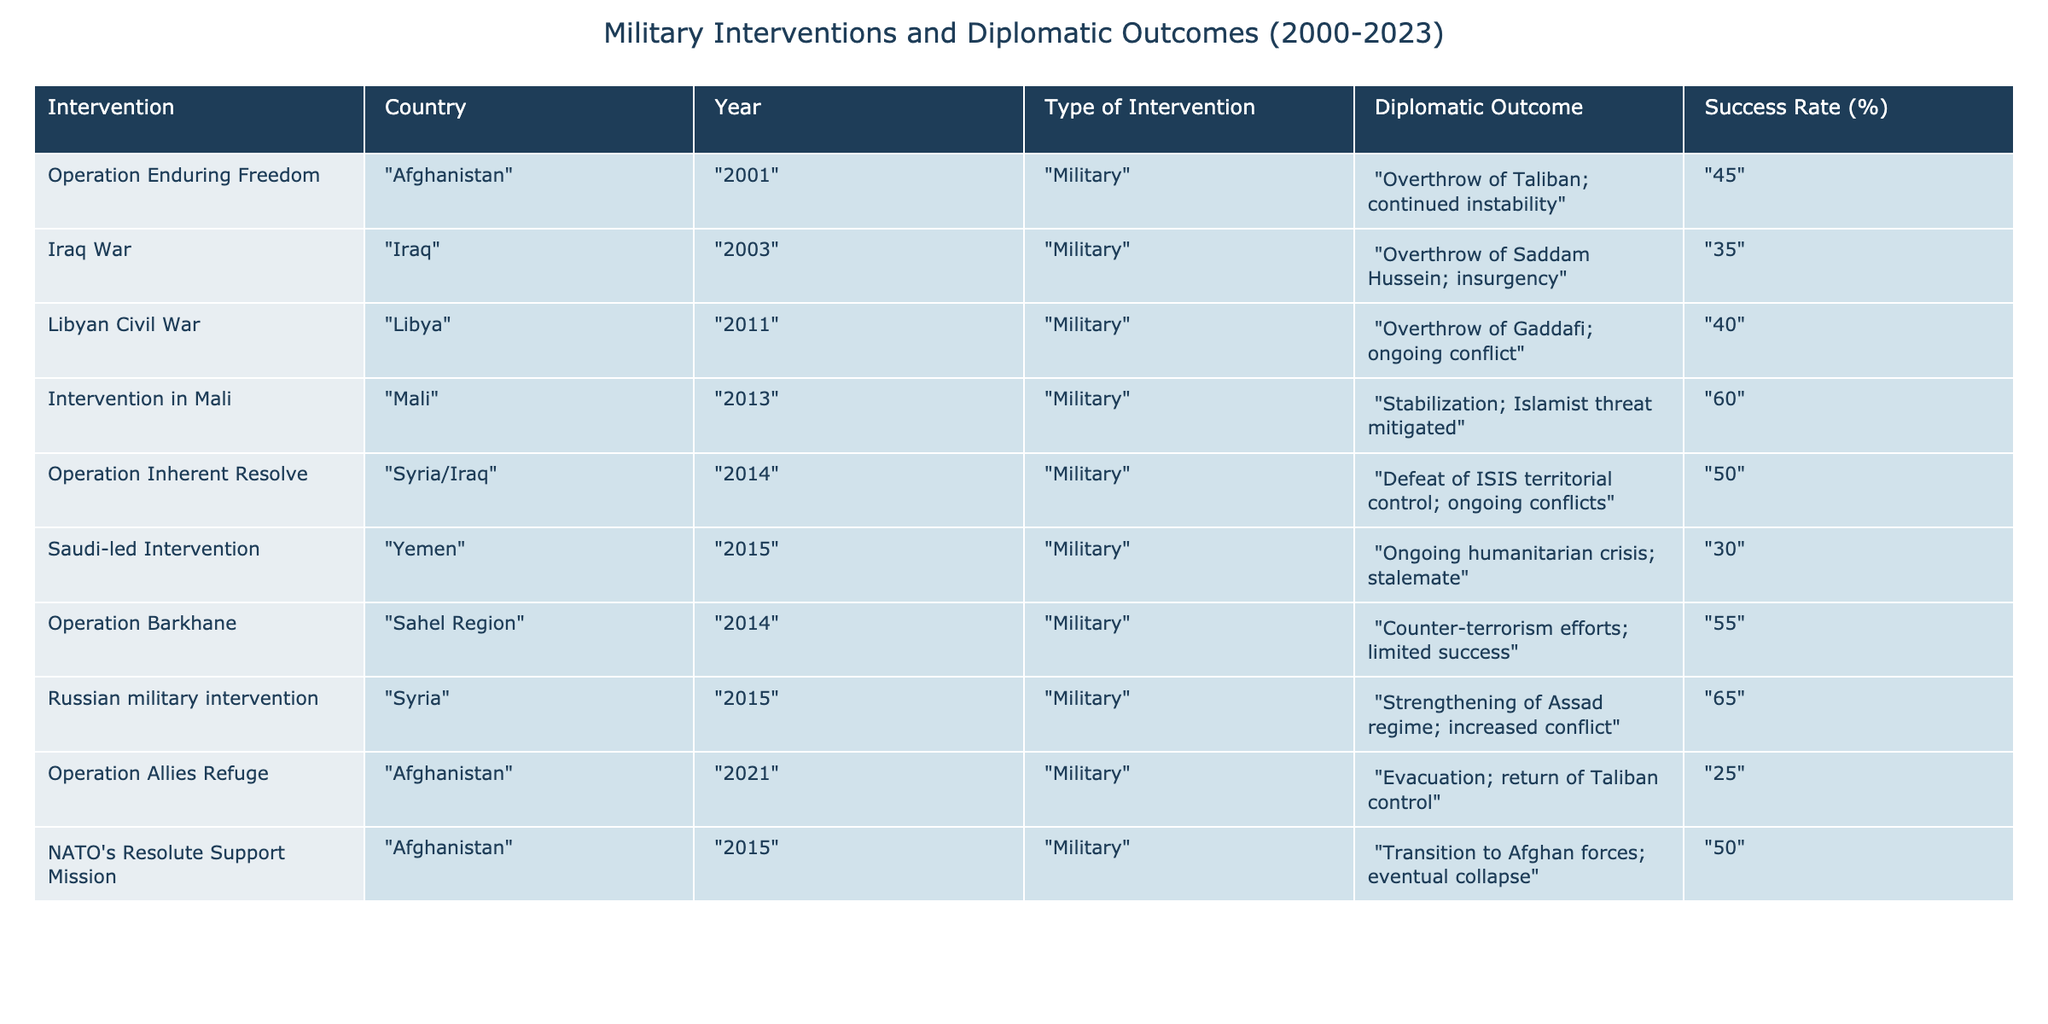What military intervention had the highest success rate? By examining the "Success Rate (%)" column, I see that the "Russian military intervention" in Syria has the highest success rate at 65%.
Answer: 65% What was the diplomatic outcome of the Iraq War? The table lists the diplomatic outcome of the Iraq War as the "Overthrow of Saddam Hussein; insurgency."
Answer: Overthrow of Saddam Hussein; insurgency Is the success rate of the Saudi-led intervention in Yemen greater than 40%? The table indicates that the success rate for the Saudi-led intervention in Yemen is 30%, which is not greater than 40%.
Answer: No What is the average success rate of interventions listed in Afghanistan? The success rates for Afghanistan interventions are 45%, 25%, and 50%. Summing these gives 45 + 25 + 50 = 120; dividing by 3 (the number of interventions) gives an average of 40%.
Answer: 40% Did any intervention lead to a stabilization outcome? Looking through the "Diplomatic Outcome" column, the "Intervention in Mali" indicates a stabilization outcome, which confirms that there was at least one case of stabilization.
Answer: Yes What was the success rate difference between the "Operation Enduring Freedom" and the "Iraq War"? The success rate for "Operation Enduring Freedom" is 45% and for the "Iraq War" is 35%. The difference is 45 - 35 = 10%.
Answer: 10% Which intervention had an ongoing humanitarian crisis as its outcome? Referring to the "Diplomatic Outcome," the "Saudi-led Intervention" in Yemen describes an ongoing humanitarian crisis.
Answer: Saudi-led Intervention How many interventions had a success rate of 50% or higher? The interventions with a success rate of 50% or higher are: "Intervention in Mali" (60%), "Operation Inherent Resolve" (50%), and "Russian military intervention" (65%). This totals three interventions.
Answer: 3 What diplomatic outcome was common among interventions leading to regime changes? The interventions resulting in regime changes, such as "Operation Enduring Freedom," "Iraq War," and "Libyan Civil War," all had outcomes that involved overthrowing a regime but were followed by instability or conflict.
Answer: Overthrow of a regime leading to instability or conflict 